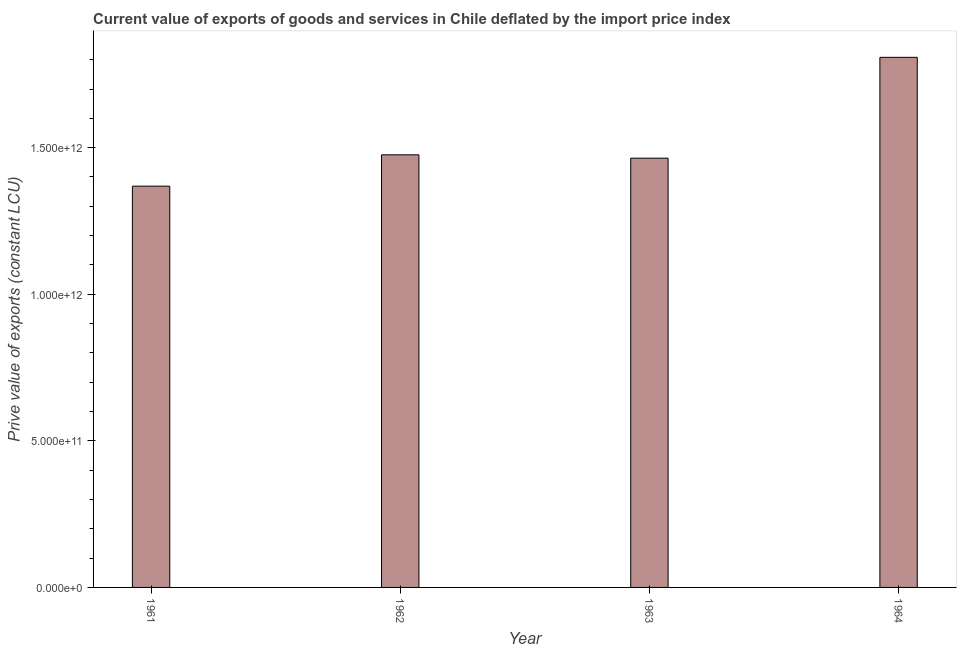Does the graph contain any zero values?
Provide a short and direct response. No. Does the graph contain grids?
Provide a succinct answer. No. What is the title of the graph?
Provide a short and direct response. Current value of exports of goods and services in Chile deflated by the import price index. What is the label or title of the X-axis?
Provide a short and direct response. Year. What is the label or title of the Y-axis?
Give a very brief answer. Prive value of exports (constant LCU). What is the price value of exports in 1961?
Ensure brevity in your answer.  1.37e+12. Across all years, what is the maximum price value of exports?
Offer a very short reply. 1.81e+12. Across all years, what is the minimum price value of exports?
Provide a short and direct response. 1.37e+12. In which year was the price value of exports maximum?
Make the answer very short. 1964. In which year was the price value of exports minimum?
Ensure brevity in your answer.  1961. What is the sum of the price value of exports?
Ensure brevity in your answer.  6.12e+12. What is the difference between the price value of exports in 1963 and 1964?
Provide a succinct answer. -3.44e+11. What is the average price value of exports per year?
Provide a short and direct response. 1.53e+12. What is the median price value of exports?
Your response must be concise. 1.47e+12. In how many years, is the price value of exports greater than 100000000000 LCU?
Your answer should be very brief. 4. What is the ratio of the price value of exports in 1962 to that in 1963?
Ensure brevity in your answer.  1.01. Is the price value of exports in 1961 less than that in 1964?
Offer a terse response. Yes. What is the difference between the highest and the second highest price value of exports?
Give a very brief answer. 3.33e+11. Is the sum of the price value of exports in 1962 and 1963 greater than the maximum price value of exports across all years?
Your answer should be compact. Yes. What is the difference between the highest and the lowest price value of exports?
Your response must be concise. 4.39e+11. Are all the bars in the graph horizontal?
Keep it short and to the point. No. How many years are there in the graph?
Provide a succinct answer. 4. What is the difference between two consecutive major ticks on the Y-axis?
Keep it short and to the point. 5.00e+11. What is the Prive value of exports (constant LCU) in 1961?
Ensure brevity in your answer.  1.37e+12. What is the Prive value of exports (constant LCU) in 1962?
Provide a succinct answer. 1.48e+12. What is the Prive value of exports (constant LCU) of 1963?
Provide a succinct answer. 1.46e+12. What is the Prive value of exports (constant LCU) of 1964?
Your answer should be very brief. 1.81e+12. What is the difference between the Prive value of exports (constant LCU) in 1961 and 1962?
Offer a terse response. -1.07e+11. What is the difference between the Prive value of exports (constant LCU) in 1961 and 1963?
Provide a succinct answer. -9.54e+1. What is the difference between the Prive value of exports (constant LCU) in 1961 and 1964?
Your answer should be very brief. -4.39e+11. What is the difference between the Prive value of exports (constant LCU) in 1962 and 1963?
Your answer should be compact. 1.15e+1. What is the difference between the Prive value of exports (constant LCU) in 1962 and 1964?
Provide a short and direct response. -3.33e+11. What is the difference between the Prive value of exports (constant LCU) in 1963 and 1964?
Your answer should be compact. -3.44e+11. What is the ratio of the Prive value of exports (constant LCU) in 1961 to that in 1962?
Make the answer very short. 0.93. What is the ratio of the Prive value of exports (constant LCU) in 1961 to that in 1963?
Your answer should be very brief. 0.94. What is the ratio of the Prive value of exports (constant LCU) in 1961 to that in 1964?
Provide a short and direct response. 0.76. What is the ratio of the Prive value of exports (constant LCU) in 1962 to that in 1963?
Your answer should be compact. 1.01. What is the ratio of the Prive value of exports (constant LCU) in 1962 to that in 1964?
Provide a short and direct response. 0.82. What is the ratio of the Prive value of exports (constant LCU) in 1963 to that in 1964?
Provide a short and direct response. 0.81. 